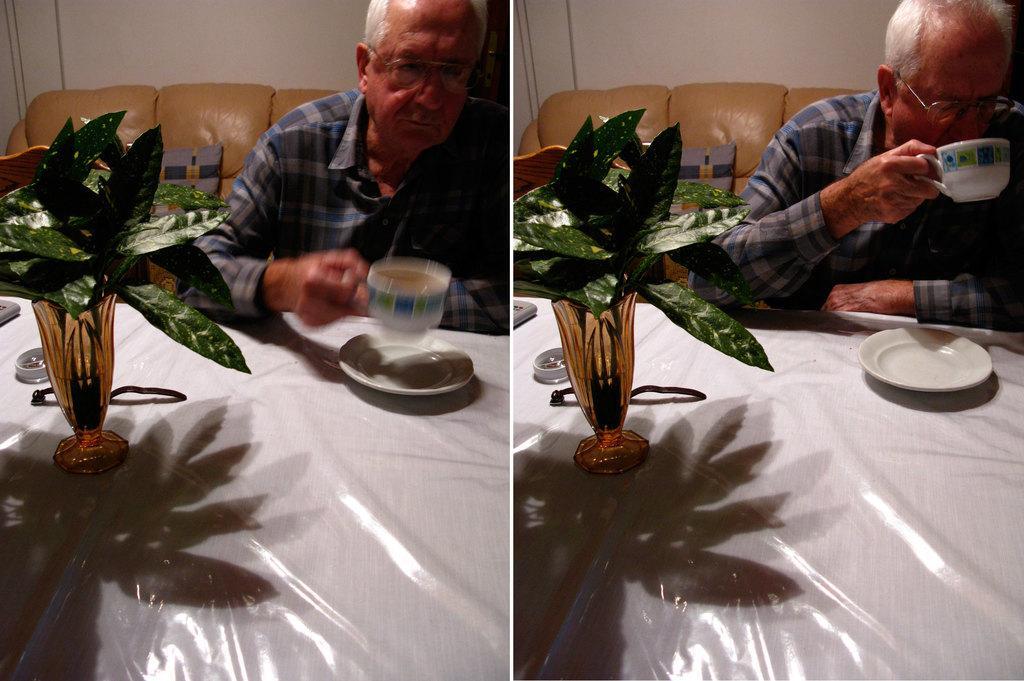In one or two sentences, can you explain what this image depicts? In this image i can see a replica of the image. And a man sitting on the couch and it is attached to the wall and a man wearing a blue color shirt and holding a coffee cup and there is a saucer kept on the table. and there is a flower pot kept on the table. there is a green color leaf on the flower pot. 